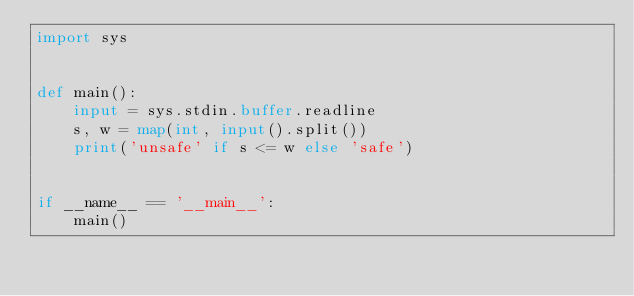Convert code to text. <code><loc_0><loc_0><loc_500><loc_500><_Python_>import sys


def main():
    input = sys.stdin.buffer.readline
    s, w = map(int, input().split())
    print('unsafe' if s <= w else 'safe')


if __name__ == '__main__':
    main()
</code> 